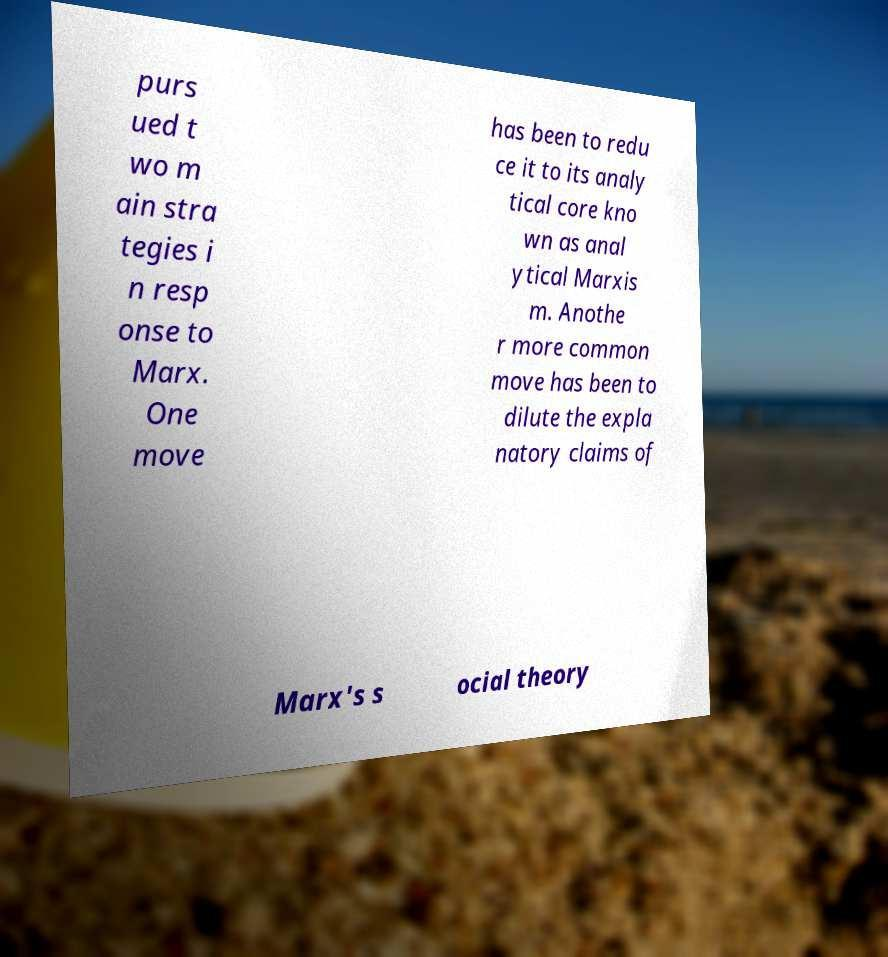I need the written content from this picture converted into text. Can you do that? purs ued t wo m ain stra tegies i n resp onse to Marx. One move has been to redu ce it to its analy tical core kno wn as anal ytical Marxis m. Anothe r more common move has been to dilute the expla natory claims of Marx's s ocial theory 